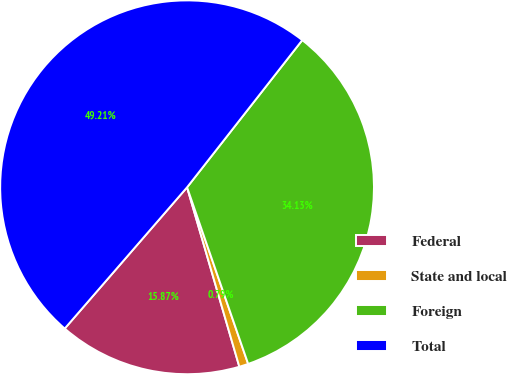Convert chart to OTSL. <chart><loc_0><loc_0><loc_500><loc_500><pie_chart><fcel>Federal<fcel>State and local<fcel>Foreign<fcel>Total<nl><fcel>15.87%<fcel>0.79%<fcel>34.13%<fcel>49.21%<nl></chart> 